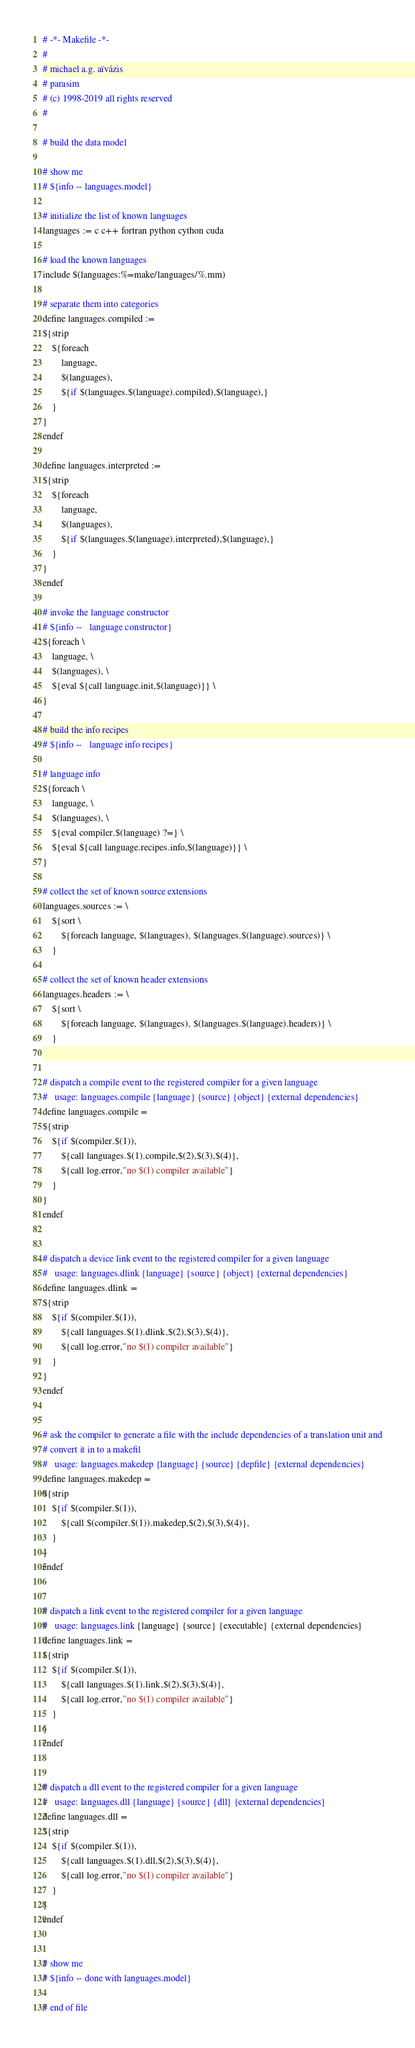Convert code to text. <code><loc_0><loc_0><loc_500><loc_500><_ObjectiveC_># -*- Makefile -*-
#
# michael a.g. aïvázis
# parasim
# (c) 1998-2019 all rights reserved
#

# build the data model

# show me
# ${info -- languages.model}

# initialize the list of known languages
languages := c c++ fortran python cython cuda

# load the known languages
include $(languages:%=make/languages/%.mm)

# separate them into categories
define languages.compiled :=
${strip
    ${foreach
        language,
        $(languages),
        ${if $(languages.$(language).compiled),$(language),}
    }
}
endef

define languages.interpreted :=
${strip
    ${foreach
        language,
        $(languages),
        ${if $(languages.$(language).interpreted),$(language),}
    }
}
endef

# invoke the language constructor
# ${info --   language constructor}
${foreach \
    language, \
    $(languages), \
    ${eval ${call language.init,$(language)}} \
}

# build the info recipes
# ${info --   language info recipes}

# language info
${foreach \
    language, \
    $(languages), \
    ${eval compiler.$(language) ?=} \
    ${eval ${call language.recipes.info,$(language)}} \
}

# collect the set of known source extensions
languages.sources := \
    ${sort \
        ${foreach language, $(languages), $(languages.$(language).sources)} \
    }

# collect the set of known header extensions
languages.headers := \
    ${sort \
        ${foreach language, $(languages), $(languages.$(language).headers)} \
    }


# dispatch a compile event to the registered compiler for a given language
#   usage: languages.compile {language} {source} {object} {external dependencies}
define languages.compile =
${strip
    ${if $(compiler.$(1)),
        ${call languages.$(1).compile,$(2),$(3),$(4)},
        ${call log.error,"no $(1) compiler available"}
    }
}
endef


# dispatch a device link event to the registered compiler for a given language
#   usage: languages.dlink {language} {source} {object} {external dependencies}
define languages.dlink =
${strip
    ${if $(compiler.$(1)),
        ${call languages.$(1).dlink,$(2),$(3),$(4)},
        ${call log.error,"no $(1) compiler available"}
    }
}
endef


# ask the compiler to generate a file with the include dependencies of a translation unit and
# convert it in to a makefil
#   usage: languages.makedep {language} {source} {depfile} {external dependencies}
define languages.makedep =
${strip
    ${if $(compiler.$(1)),
        ${call $(compiler.$(1)).makedep,$(2),$(3),$(4)},
    }
}
endef


# dispatch a link event to the registered compiler for a given language
#   usage: languages.link {language} {source} {executable} {external dependencies}
define languages.link =
${strip
    ${if $(compiler.$(1)),
        ${call languages.$(1).link,$(2),$(3),$(4)},
        ${call log.error,"no $(1) compiler available"}
    }
}
endef


# dispatch a dll event to the registered compiler for a given language
#   usage: languages.dll {language} {source} {dll} {external dependencies}
define languages.dll =
${strip
    ${if $(compiler.$(1)),
        ${call languages.$(1).dll,$(2),$(3),$(4)},
        ${call log.error,"no $(1) compiler available"}
    }
}
endef


# show me
# ${info -- done with languages.model}

# end of file
</code> 